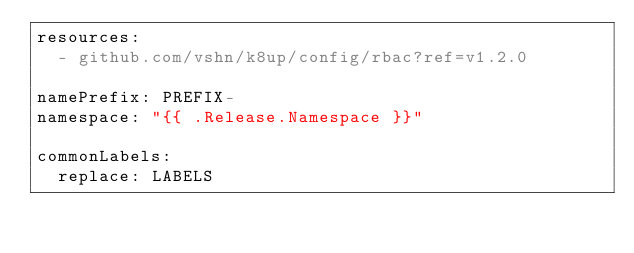Convert code to text. <code><loc_0><loc_0><loc_500><loc_500><_YAML_>resources:
  - github.com/vshn/k8up/config/rbac?ref=v1.2.0

namePrefix: PREFIX-
namespace: "{{ .Release.Namespace }}"

commonLabels:
  replace: LABELS
</code> 